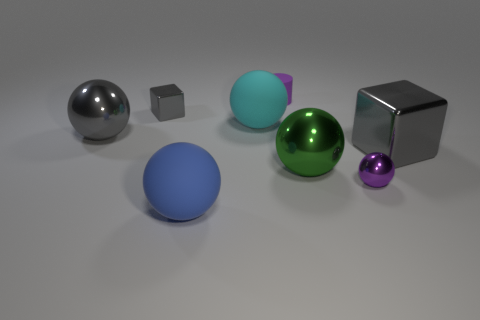What number of large objects are the same color as the large metallic cube?
Keep it short and to the point. 1. There is a cube that is the same size as the rubber cylinder; what is it made of?
Make the answer very short. Metal. There is a big gray metal object right of the large blue matte ball; is there a gray metallic sphere on the right side of it?
Your answer should be compact. No. How many other things are there of the same color as the large metal block?
Ensure brevity in your answer.  2. What is the size of the cyan matte thing?
Give a very brief answer. Large. Is there a tiny gray shiny block?
Ensure brevity in your answer.  Yes. Are there more large rubber spheres that are behind the tiny gray metal block than gray shiny objects to the left of the purple rubber thing?
Offer a terse response. No. What material is the big ball that is behind the big gray metal cube and to the right of the tiny gray metal object?
Provide a succinct answer. Rubber. Is the big cyan matte thing the same shape as the green object?
Provide a short and direct response. Yes. Is there any other thing that is the same size as the purple metal sphere?
Offer a terse response. Yes. 